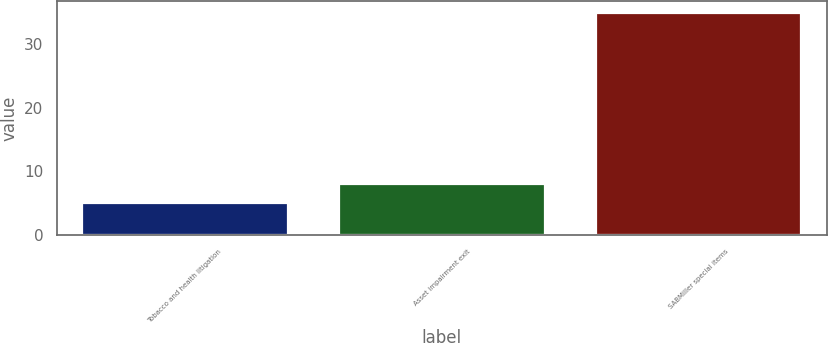Convert chart. <chart><loc_0><loc_0><loc_500><loc_500><bar_chart><fcel>Tobacco and health litigation<fcel>Asset impairment exit<fcel>SABMiller special items<nl><fcel>5<fcel>8<fcel>35<nl></chart> 